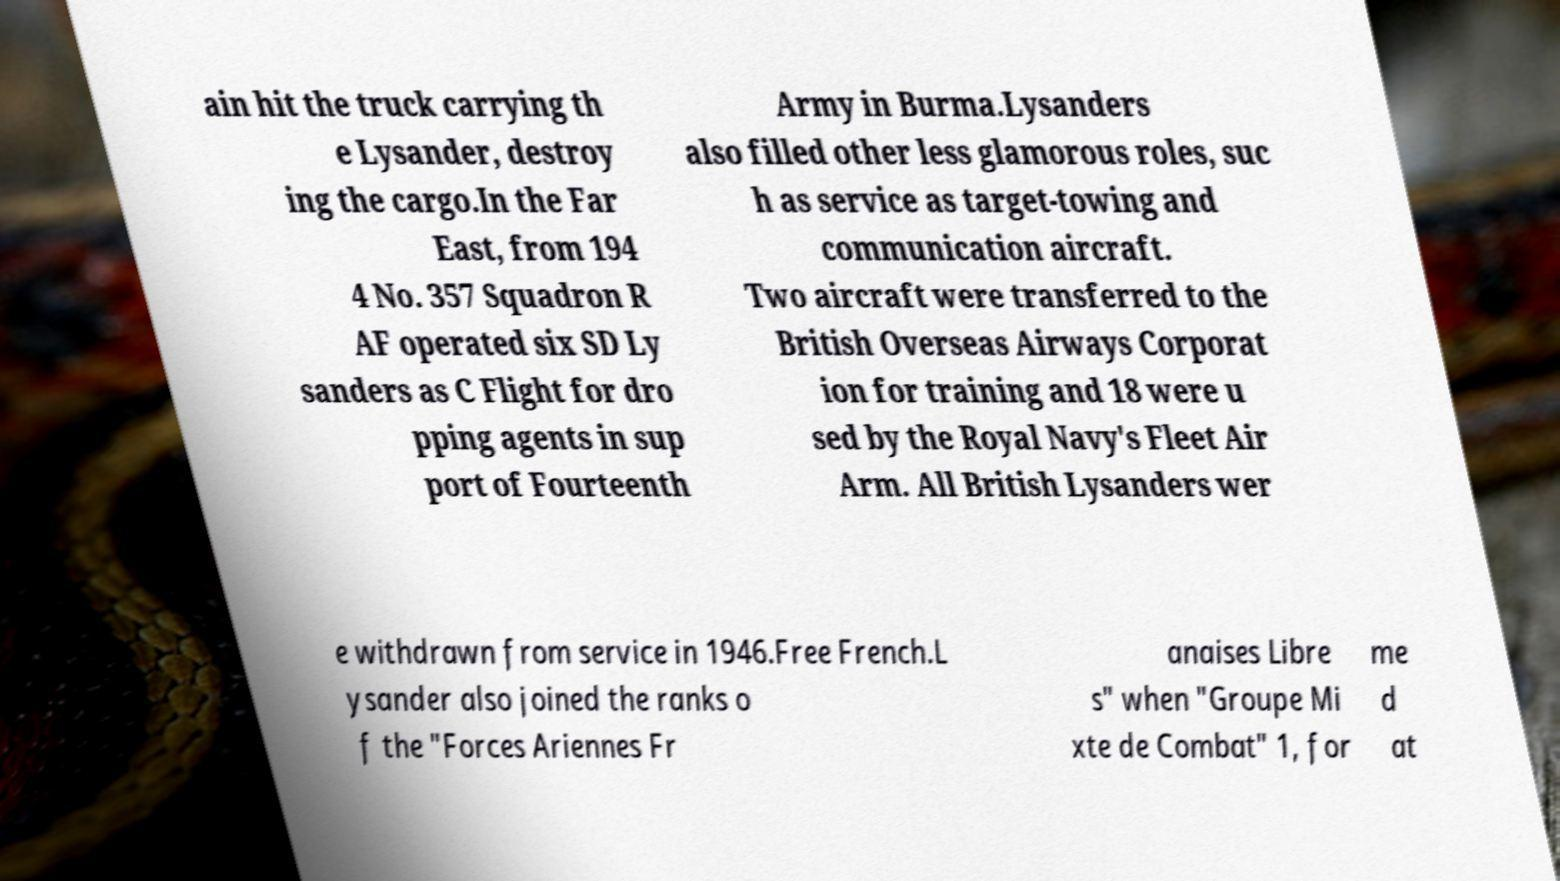I need the written content from this picture converted into text. Can you do that? ain hit the truck carrying th e Lysander, destroy ing the cargo.In the Far East, from 194 4 No. 357 Squadron R AF operated six SD Ly sanders as C Flight for dro pping agents in sup port of Fourteenth Army in Burma.Lysanders also filled other less glamorous roles, suc h as service as target-towing and communication aircraft. Two aircraft were transferred to the British Overseas Airways Corporat ion for training and 18 were u sed by the Royal Navy's Fleet Air Arm. All British Lysanders wer e withdrawn from service in 1946.Free French.L ysander also joined the ranks o f the "Forces Ariennes Fr anaises Libre s" when "Groupe Mi xte de Combat" 1, for me d at 